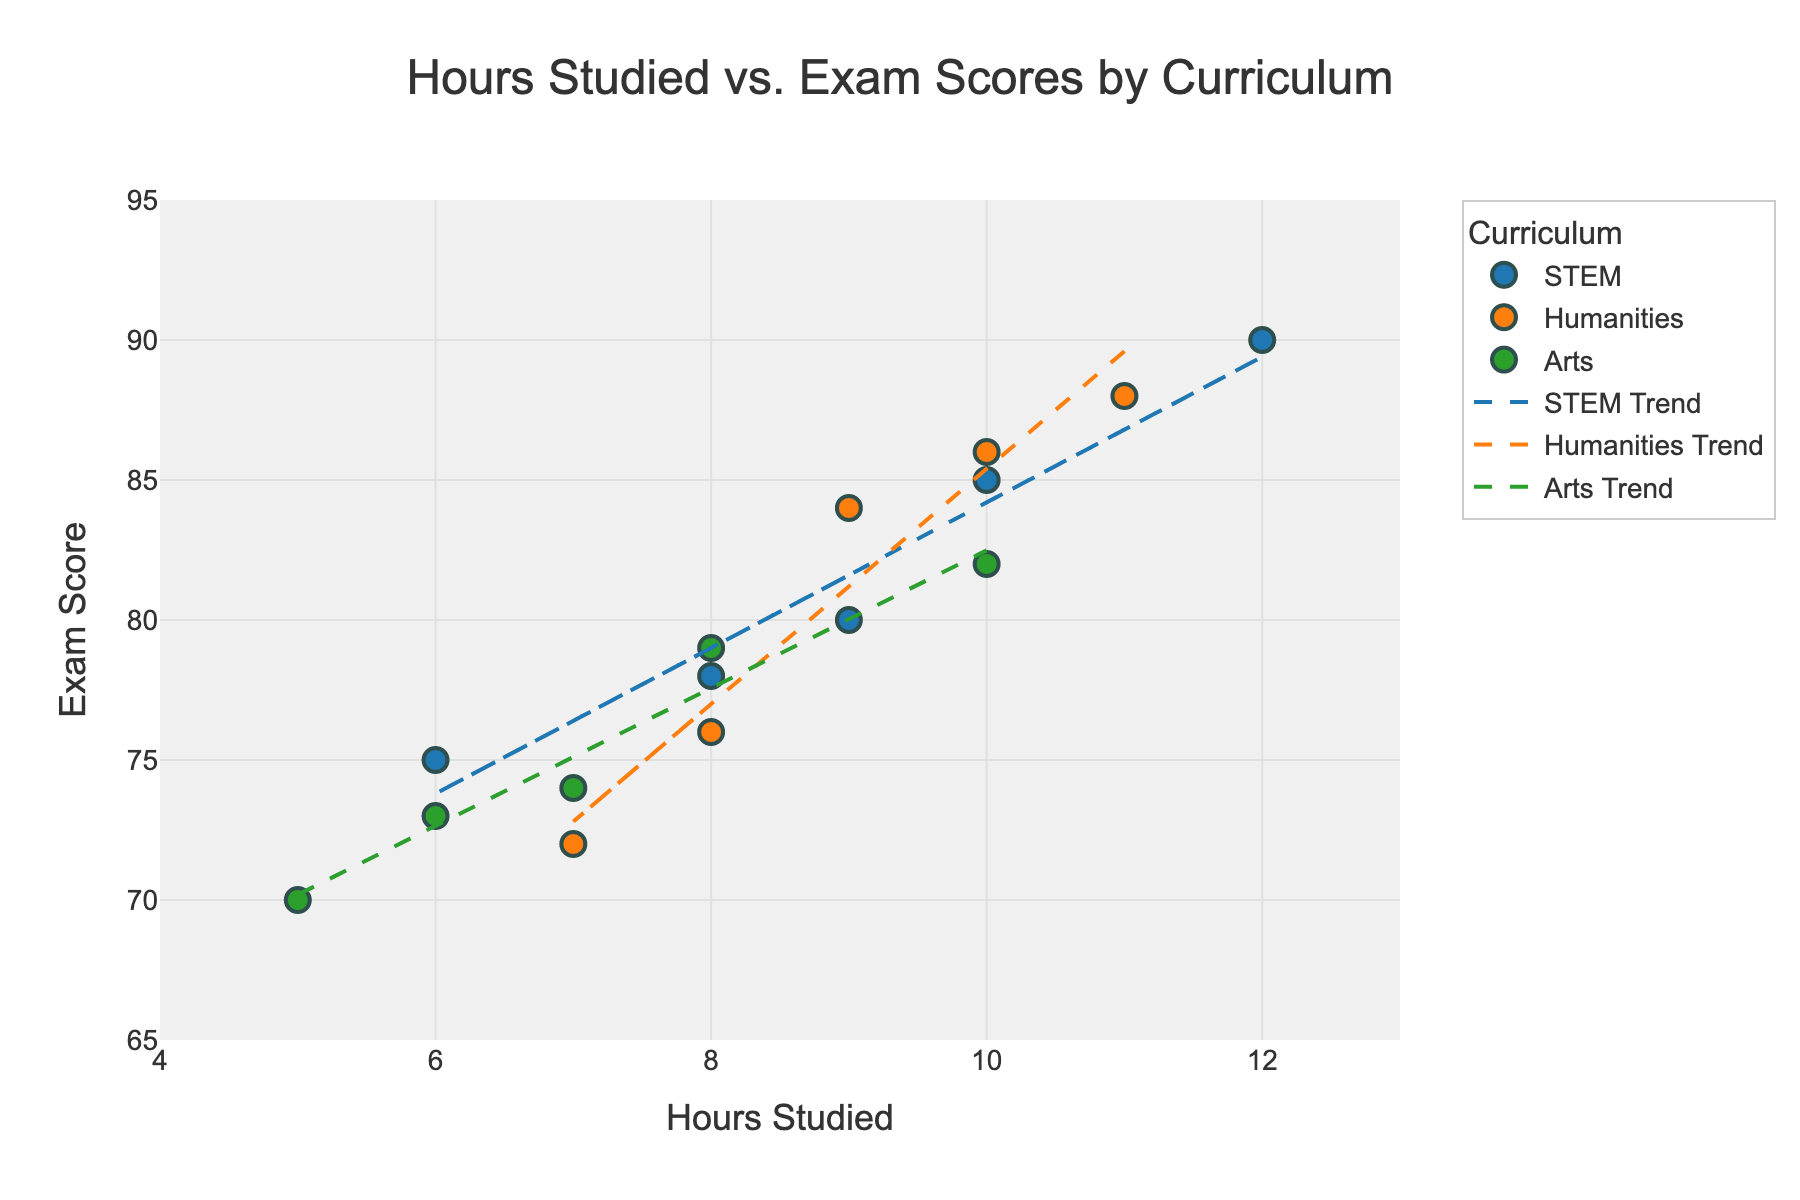How many data points are there for each curriculum? By counting each scatter plot point, we find that there are 5 data points each for the STEM, Humanities, and Arts curricula.
Answer: 5 for each curriculum Which curriculum shows the highest exam score? By looking at the highest points on the y-axis (Exam Score), the STEM curriculum has the highest exam score at 90.
Answer: STEM What's the range of hours studied among all students? The x-axis (Hours Studied) ranges from the minimum value of 5 hours to the maximum value of 12 hours.
Answer: 5 to 12 hours Which curriculum has the highest trend line slope? The steepness of the line shows the slope; the STEM trend line appears steeper compared to Humanities and Arts, indicating a higher slope.
Answer: STEM What is the approximate exam score for a student studying 10 hours in the Arts curriculum? By referencing the Arts trend line at 10 hours on the x-axis, the score is around 80-82.
Answer: 82 How do exam scores change with increased hours studied in the Humanities curriculum? By observing the upward trend of the Humanities trend line, exam scores increase as hours studied increase.
Answer: Increase Compare the starting point (low end) and the endpoint (high end) of the trend lines for the STEM and Arts curricula. For the STEM curriculum, the trend line starts around 75 and ends close to 90. For the Arts curriculum, it starts around 70 and ends around 82-83. The STEM curriculum shows a steeper increase.
Answer: STEM: 75 to 90, Arts: 70 to 82-83 What is the difference in exam scores between students who studied 11 hours in Humanities and 10 hours in STEM? From the individual points, the score for Humanities at 11 hours is 88, and for STEM at 10 hours is 85. The difference is 88 - 85.
Answer: 3 What's the average exam score of students studying more than 8 hours across all curricula? Identify points with Hours Studied > 8, which are (10, 85), (12, 90), (9, 80), (11, 88), (9, 84), (10, 86), (10, 82). The average is (85+90+80+88+84+86+82) / 7 = 85.
Answer: 85 